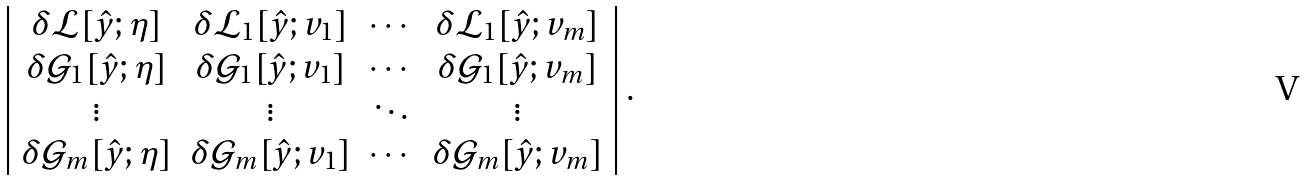Convert formula to latex. <formula><loc_0><loc_0><loc_500><loc_500>\left | \begin{array} { c c c c } \delta \mathcal { L } [ \hat { y } ; \eta ] & \delta \mathcal { L } _ { 1 } [ \hat { y } ; v _ { 1 } ] & \cdots & \delta \mathcal { L } _ { 1 } [ \hat { y } ; v _ { m } ] \\ \delta \mathcal { G } _ { 1 } [ \hat { y } ; \eta ] & \delta \mathcal { G } _ { 1 } [ \hat { y } ; v _ { 1 } ] & \cdots & \delta \mathcal { G } _ { 1 } [ \hat { y } ; v _ { m } ] \\ \vdots & \vdots & \ddots & \vdots \\ \delta \mathcal { G } _ { m } [ \hat { y } ; \eta ] & \delta \mathcal { G } _ { m } [ \hat { y } ; v _ { 1 } ] & \cdots & \delta \mathcal { G } _ { m } [ \hat { y } ; v _ { m } ] \\ \end{array} \right | .</formula> 